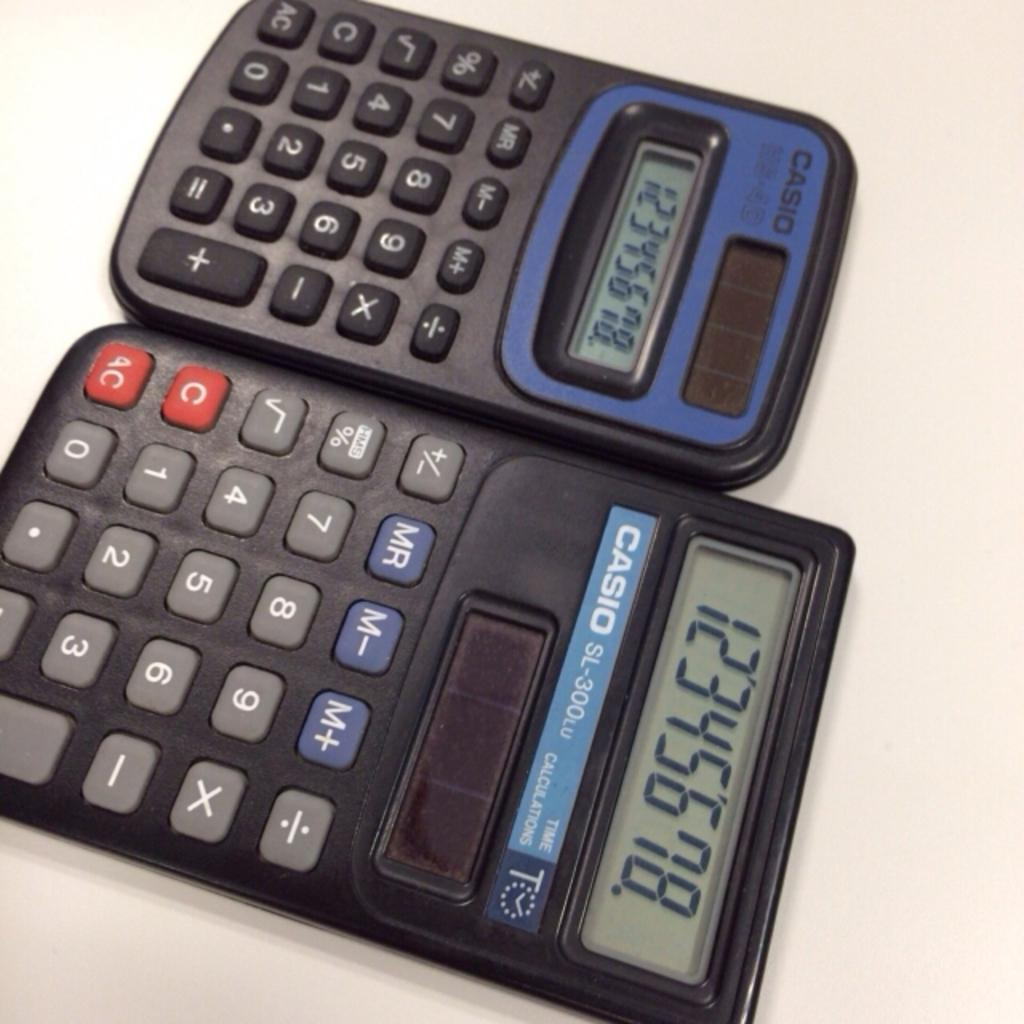<image>
Give a short and clear explanation of the subsequent image. Two Casio calculators sit next to each other and show the same number. 